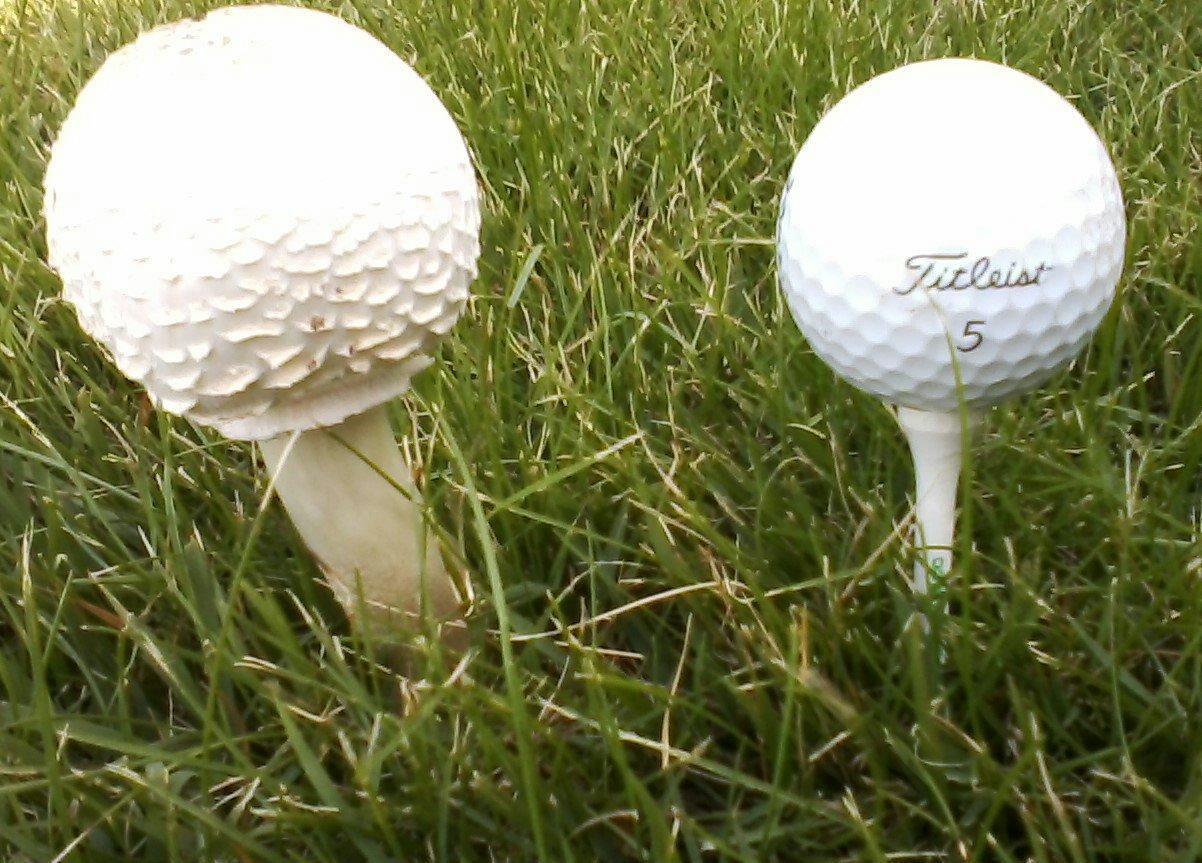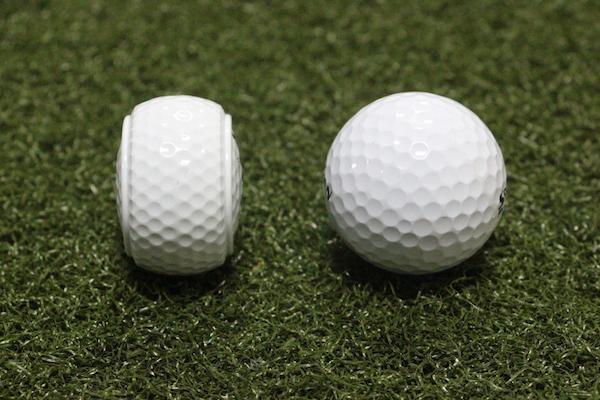The first image is the image on the left, the second image is the image on the right. Examine the images to the left and right. Is the description "There are two balls sitting directly on the grass." accurate? Answer yes or no. Yes. 